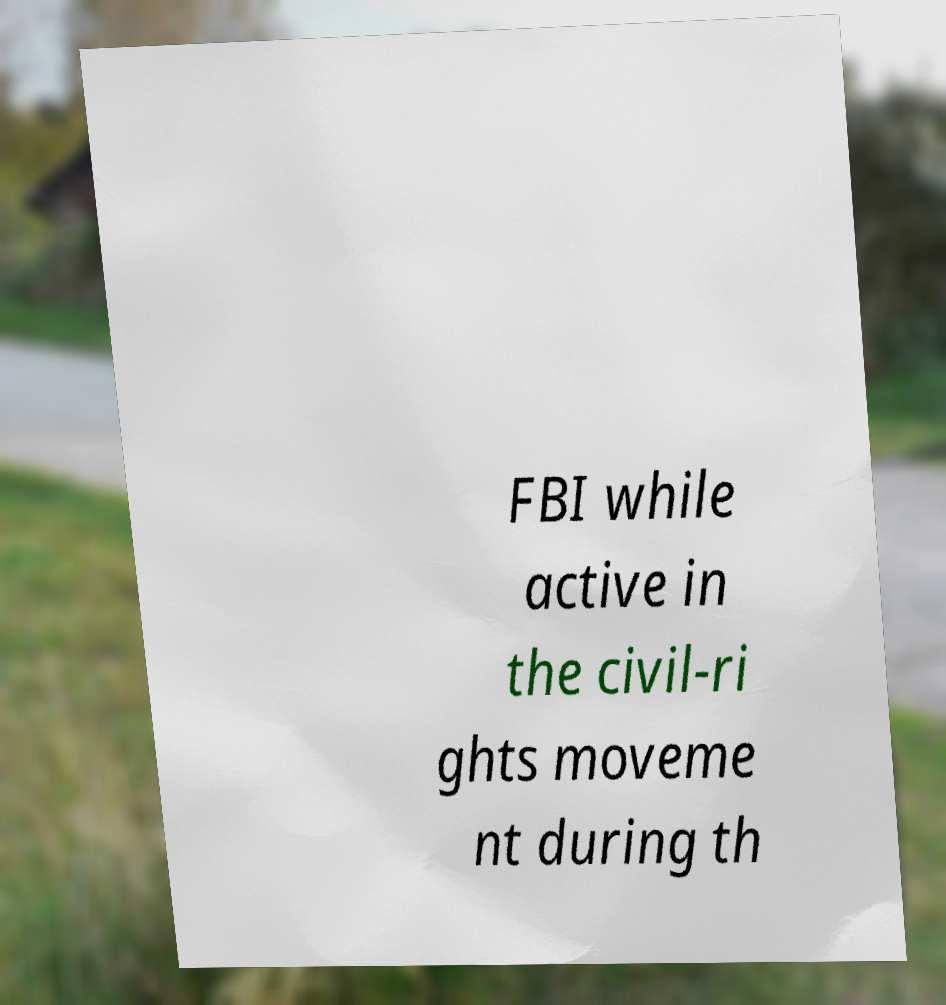Can you read and provide the text displayed in the image?This photo seems to have some interesting text. Can you extract and type it out for me? FBI while active in the civil-ri ghts moveme nt during th 